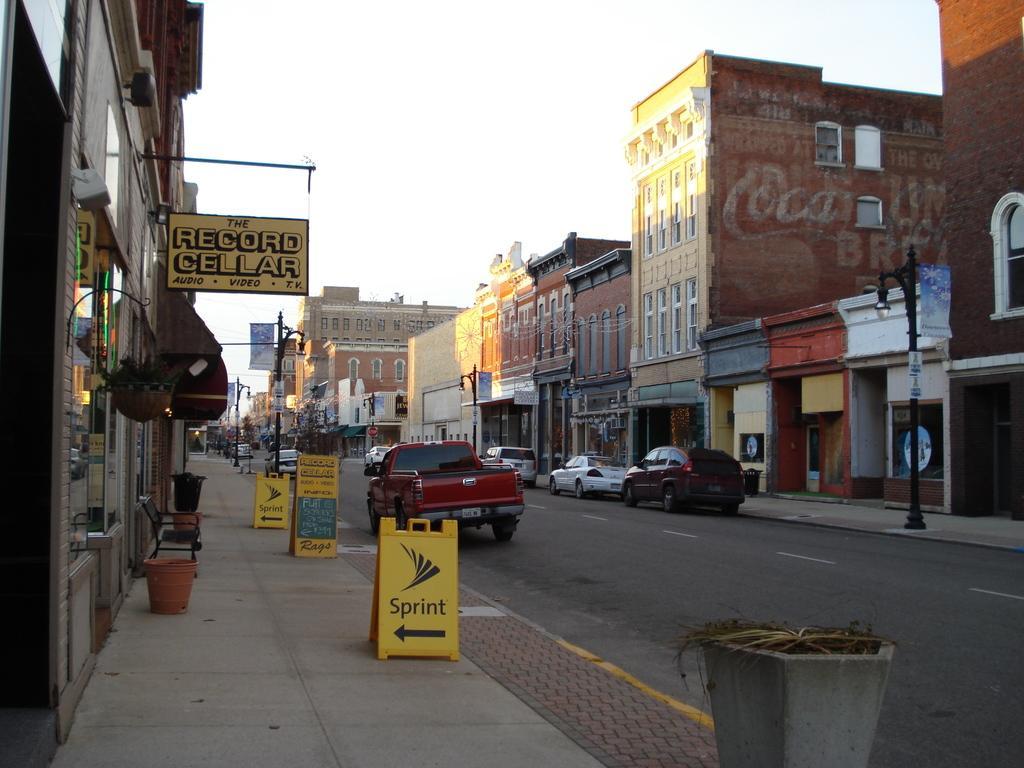In one or two sentences, can you explain what this image depicts? In the center of the image we can see a few vehicles on the road. In the bottom right side of the image, we can see one plant pot. In the background, we can see the sky, clouds, buildings, banners, poles, windows, plant pots, one chair, sign boards and a few other objects. 